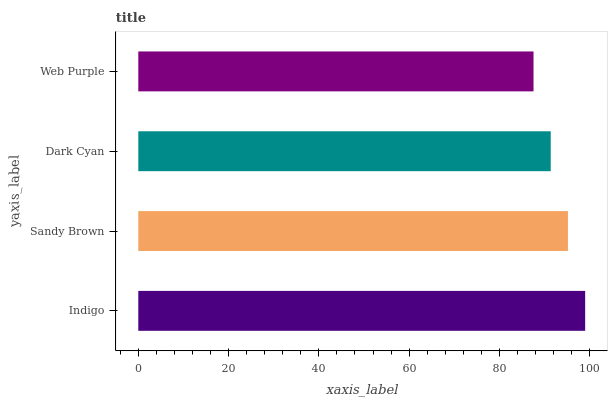Is Web Purple the minimum?
Answer yes or no. Yes. Is Indigo the maximum?
Answer yes or no. Yes. Is Sandy Brown the minimum?
Answer yes or no. No. Is Sandy Brown the maximum?
Answer yes or no. No. Is Indigo greater than Sandy Brown?
Answer yes or no. Yes. Is Sandy Brown less than Indigo?
Answer yes or no. Yes. Is Sandy Brown greater than Indigo?
Answer yes or no. No. Is Indigo less than Sandy Brown?
Answer yes or no. No. Is Sandy Brown the high median?
Answer yes or no. Yes. Is Dark Cyan the low median?
Answer yes or no. Yes. Is Web Purple the high median?
Answer yes or no. No. Is Web Purple the low median?
Answer yes or no. No. 